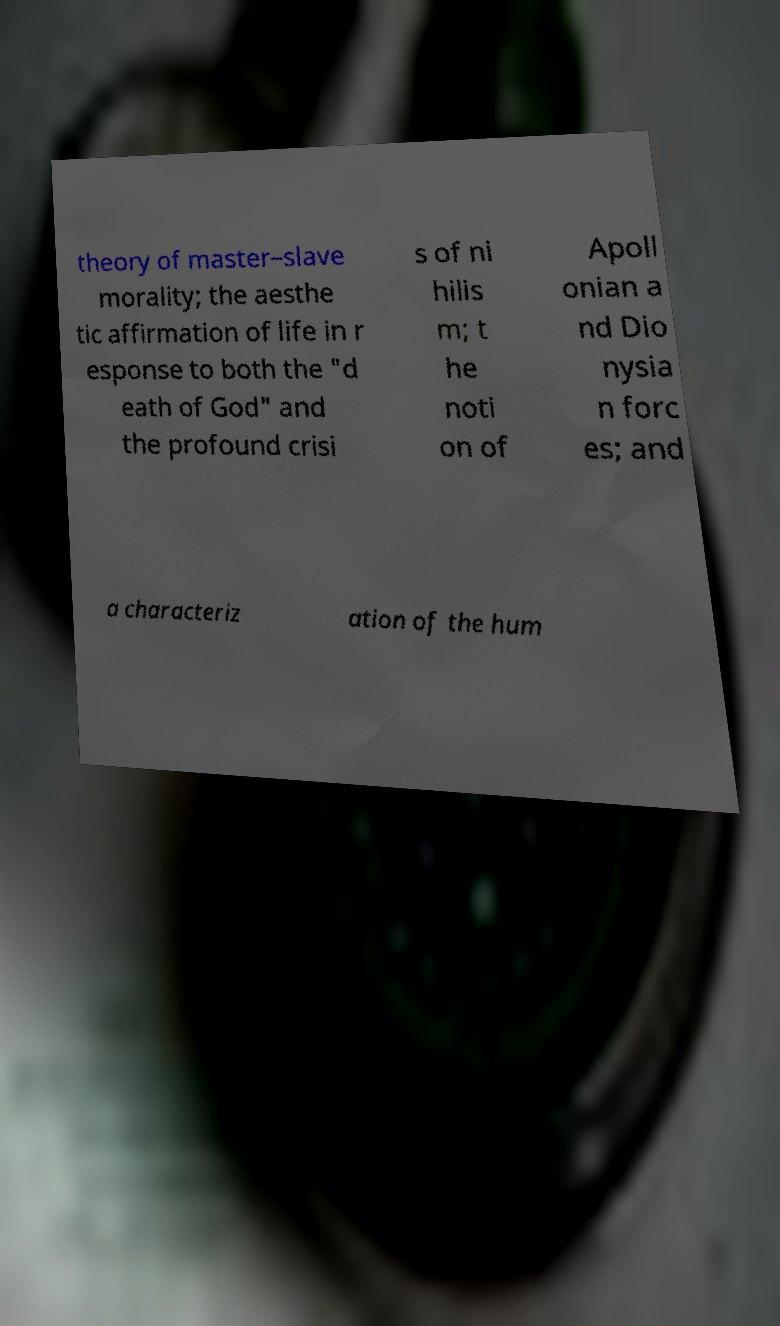Could you assist in decoding the text presented in this image and type it out clearly? theory of master–slave morality; the aesthe tic affirmation of life in r esponse to both the "d eath of God" and the profound crisi s of ni hilis m; t he noti on of Apoll onian a nd Dio nysia n forc es; and a characteriz ation of the hum 